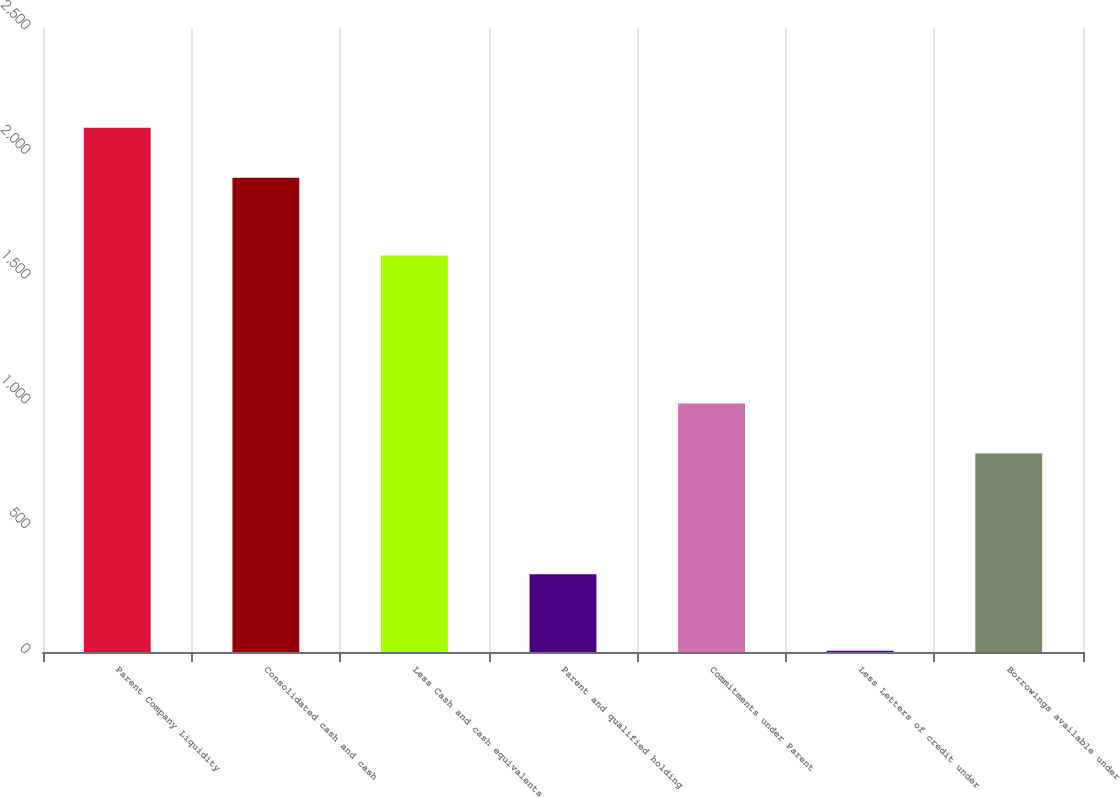Convert chart to OTSL. <chart><loc_0><loc_0><loc_500><loc_500><bar_chart><fcel>Parent Company Liquidity<fcel>Consolidated cash and cash<fcel>Less Cash and cash equivalents<fcel>Parent and qualified holding<fcel>Commitments under Parent<fcel>Less Letters of credit under<fcel>Borrowings available under<nl><fcel>2100.7<fcel>1900<fcel>1589<fcel>311<fcel>995.7<fcel>5<fcel>795<nl></chart> 